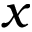<formula> <loc_0><loc_0><loc_500><loc_500>x</formula> 